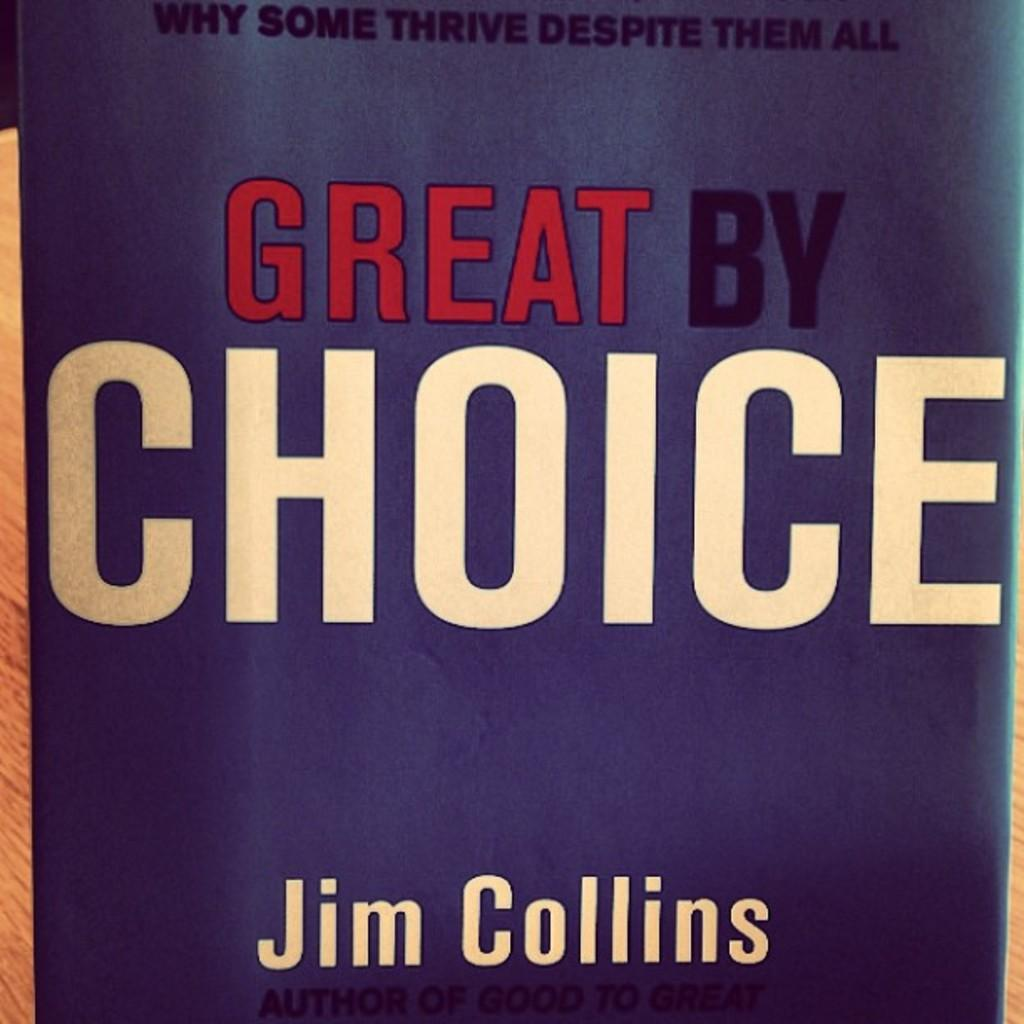<image>
Give a short and clear explanation of the subsequent image. The book cover of Great By Choice by Jim Collins 